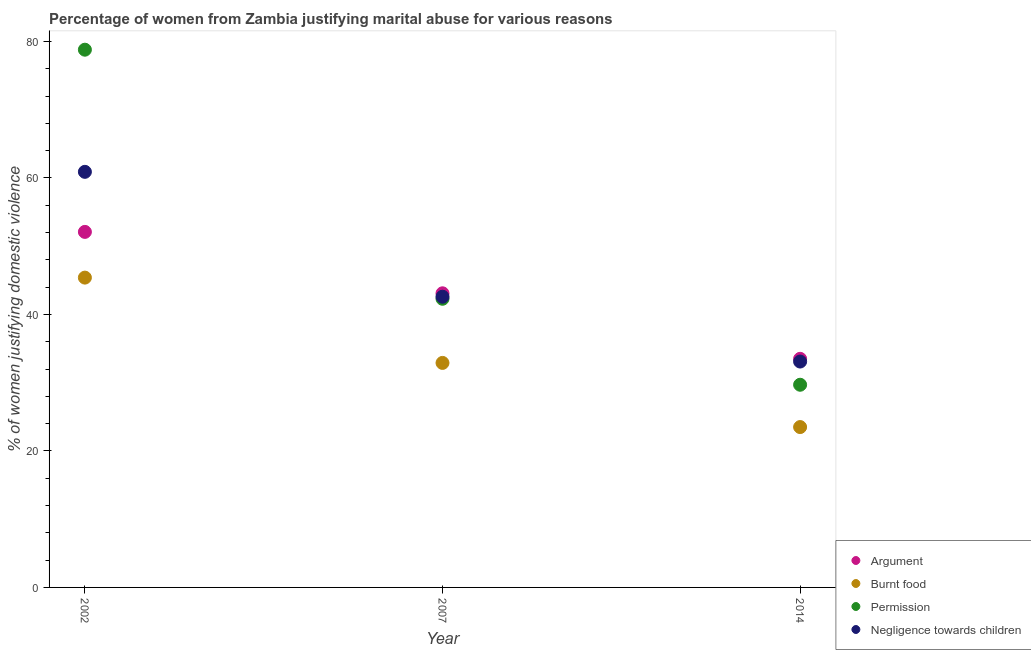How many different coloured dotlines are there?
Make the answer very short. 4. Is the number of dotlines equal to the number of legend labels?
Offer a terse response. Yes. What is the percentage of women justifying abuse for going without permission in 2007?
Give a very brief answer. 42.3. Across all years, what is the maximum percentage of women justifying abuse in the case of an argument?
Your answer should be very brief. 52.1. Across all years, what is the minimum percentage of women justifying abuse for showing negligence towards children?
Your response must be concise. 33.1. In which year was the percentage of women justifying abuse in the case of an argument maximum?
Your answer should be compact. 2002. In which year was the percentage of women justifying abuse for burning food minimum?
Keep it short and to the point. 2014. What is the total percentage of women justifying abuse for showing negligence towards children in the graph?
Your answer should be compact. 136.6. What is the difference between the percentage of women justifying abuse for going without permission in 2007 and that in 2014?
Offer a terse response. 12.6. What is the difference between the percentage of women justifying abuse for burning food in 2007 and the percentage of women justifying abuse for going without permission in 2002?
Keep it short and to the point. -45.9. What is the average percentage of women justifying abuse in the case of an argument per year?
Ensure brevity in your answer.  42.9. In the year 2007, what is the difference between the percentage of women justifying abuse for going without permission and percentage of women justifying abuse for burning food?
Offer a very short reply. 9.4. In how many years, is the percentage of women justifying abuse for showing negligence towards children greater than 16 %?
Your answer should be compact. 3. What is the ratio of the percentage of women justifying abuse for showing negligence towards children in 2002 to that in 2014?
Ensure brevity in your answer.  1.84. What is the difference between the highest and the lowest percentage of women justifying abuse for showing negligence towards children?
Provide a short and direct response. 27.8. In how many years, is the percentage of women justifying abuse for showing negligence towards children greater than the average percentage of women justifying abuse for showing negligence towards children taken over all years?
Your answer should be compact. 1. Is it the case that in every year, the sum of the percentage of women justifying abuse for burning food and percentage of women justifying abuse for showing negligence towards children is greater than the sum of percentage of women justifying abuse for going without permission and percentage of women justifying abuse in the case of an argument?
Ensure brevity in your answer.  No. Is it the case that in every year, the sum of the percentage of women justifying abuse in the case of an argument and percentage of women justifying abuse for burning food is greater than the percentage of women justifying abuse for going without permission?
Make the answer very short. Yes. Does the percentage of women justifying abuse in the case of an argument monotonically increase over the years?
Provide a short and direct response. No. How many years are there in the graph?
Make the answer very short. 3. What is the difference between two consecutive major ticks on the Y-axis?
Your answer should be compact. 20. Are the values on the major ticks of Y-axis written in scientific E-notation?
Provide a succinct answer. No. How are the legend labels stacked?
Offer a very short reply. Vertical. What is the title of the graph?
Provide a short and direct response. Percentage of women from Zambia justifying marital abuse for various reasons. Does "Finland" appear as one of the legend labels in the graph?
Give a very brief answer. No. What is the label or title of the X-axis?
Make the answer very short. Year. What is the label or title of the Y-axis?
Your answer should be very brief. % of women justifying domestic violence. What is the % of women justifying domestic violence in Argument in 2002?
Make the answer very short. 52.1. What is the % of women justifying domestic violence in Burnt food in 2002?
Your answer should be compact. 45.4. What is the % of women justifying domestic violence of Permission in 2002?
Ensure brevity in your answer.  78.8. What is the % of women justifying domestic violence in Negligence towards children in 2002?
Keep it short and to the point. 60.9. What is the % of women justifying domestic violence in Argument in 2007?
Provide a short and direct response. 43.1. What is the % of women justifying domestic violence of Burnt food in 2007?
Your response must be concise. 32.9. What is the % of women justifying domestic violence of Permission in 2007?
Offer a terse response. 42.3. What is the % of women justifying domestic violence of Negligence towards children in 2007?
Give a very brief answer. 42.6. What is the % of women justifying domestic violence of Argument in 2014?
Provide a short and direct response. 33.5. What is the % of women justifying domestic violence in Permission in 2014?
Give a very brief answer. 29.7. What is the % of women justifying domestic violence of Negligence towards children in 2014?
Your answer should be compact. 33.1. Across all years, what is the maximum % of women justifying domestic violence of Argument?
Provide a short and direct response. 52.1. Across all years, what is the maximum % of women justifying domestic violence in Burnt food?
Ensure brevity in your answer.  45.4. Across all years, what is the maximum % of women justifying domestic violence of Permission?
Offer a terse response. 78.8. Across all years, what is the maximum % of women justifying domestic violence of Negligence towards children?
Offer a terse response. 60.9. Across all years, what is the minimum % of women justifying domestic violence of Argument?
Offer a terse response. 33.5. Across all years, what is the minimum % of women justifying domestic violence in Burnt food?
Your answer should be very brief. 23.5. Across all years, what is the minimum % of women justifying domestic violence in Permission?
Ensure brevity in your answer.  29.7. Across all years, what is the minimum % of women justifying domestic violence of Negligence towards children?
Your answer should be compact. 33.1. What is the total % of women justifying domestic violence of Argument in the graph?
Ensure brevity in your answer.  128.7. What is the total % of women justifying domestic violence in Burnt food in the graph?
Your response must be concise. 101.8. What is the total % of women justifying domestic violence in Permission in the graph?
Your response must be concise. 150.8. What is the total % of women justifying domestic violence in Negligence towards children in the graph?
Keep it short and to the point. 136.6. What is the difference between the % of women justifying domestic violence of Permission in 2002 and that in 2007?
Make the answer very short. 36.5. What is the difference between the % of women justifying domestic violence of Argument in 2002 and that in 2014?
Give a very brief answer. 18.6. What is the difference between the % of women justifying domestic violence of Burnt food in 2002 and that in 2014?
Offer a very short reply. 21.9. What is the difference between the % of women justifying domestic violence of Permission in 2002 and that in 2014?
Ensure brevity in your answer.  49.1. What is the difference between the % of women justifying domestic violence in Negligence towards children in 2002 and that in 2014?
Your answer should be very brief. 27.8. What is the difference between the % of women justifying domestic violence in Argument in 2007 and that in 2014?
Provide a short and direct response. 9.6. What is the difference between the % of women justifying domestic violence of Negligence towards children in 2007 and that in 2014?
Ensure brevity in your answer.  9.5. What is the difference between the % of women justifying domestic violence in Permission in 2002 and the % of women justifying domestic violence in Negligence towards children in 2007?
Offer a very short reply. 36.2. What is the difference between the % of women justifying domestic violence of Argument in 2002 and the % of women justifying domestic violence of Burnt food in 2014?
Offer a very short reply. 28.6. What is the difference between the % of women justifying domestic violence of Argument in 2002 and the % of women justifying domestic violence of Permission in 2014?
Ensure brevity in your answer.  22.4. What is the difference between the % of women justifying domestic violence of Argument in 2002 and the % of women justifying domestic violence of Negligence towards children in 2014?
Make the answer very short. 19. What is the difference between the % of women justifying domestic violence of Permission in 2002 and the % of women justifying domestic violence of Negligence towards children in 2014?
Offer a very short reply. 45.7. What is the difference between the % of women justifying domestic violence of Argument in 2007 and the % of women justifying domestic violence of Burnt food in 2014?
Offer a terse response. 19.6. What is the difference between the % of women justifying domestic violence in Argument in 2007 and the % of women justifying domestic violence in Negligence towards children in 2014?
Your answer should be very brief. 10. What is the difference between the % of women justifying domestic violence of Burnt food in 2007 and the % of women justifying domestic violence of Permission in 2014?
Provide a short and direct response. 3.2. What is the difference between the % of women justifying domestic violence of Permission in 2007 and the % of women justifying domestic violence of Negligence towards children in 2014?
Offer a terse response. 9.2. What is the average % of women justifying domestic violence in Argument per year?
Offer a very short reply. 42.9. What is the average % of women justifying domestic violence of Burnt food per year?
Your answer should be very brief. 33.93. What is the average % of women justifying domestic violence in Permission per year?
Give a very brief answer. 50.27. What is the average % of women justifying domestic violence of Negligence towards children per year?
Your answer should be compact. 45.53. In the year 2002, what is the difference between the % of women justifying domestic violence of Argument and % of women justifying domestic violence of Permission?
Your answer should be very brief. -26.7. In the year 2002, what is the difference between the % of women justifying domestic violence in Argument and % of women justifying domestic violence in Negligence towards children?
Your response must be concise. -8.8. In the year 2002, what is the difference between the % of women justifying domestic violence in Burnt food and % of women justifying domestic violence in Permission?
Offer a terse response. -33.4. In the year 2002, what is the difference between the % of women justifying domestic violence in Burnt food and % of women justifying domestic violence in Negligence towards children?
Keep it short and to the point. -15.5. In the year 2007, what is the difference between the % of women justifying domestic violence of Argument and % of women justifying domestic violence of Permission?
Offer a terse response. 0.8. In the year 2007, what is the difference between the % of women justifying domestic violence in Burnt food and % of women justifying domestic violence in Permission?
Your answer should be very brief. -9.4. In the year 2007, what is the difference between the % of women justifying domestic violence in Burnt food and % of women justifying domestic violence in Negligence towards children?
Provide a short and direct response. -9.7. In the year 2007, what is the difference between the % of women justifying domestic violence of Permission and % of women justifying domestic violence of Negligence towards children?
Offer a very short reply. -0.3. In the year 2014, what is the difference between the % of women justifying domestic violence in Argument and % of women justifying domestic violence in Burnt food?
Provide a succinct answer. 10. In the year 2014, what is the difference between the % of women justifying domestic violence of Argument and % of women justifying domestic violence of Negligence towards children?
Offer a very short reply. 0.4. In the year 2014, what is the difference between the % of women justifying domestic violence of Burnt food and % of women justifying domestic violence of Negligence towards children?
Your answer should be compact. -9.6. In the year 2014, what is the difference between the % of women justifying domestic violence of Permission and % of women justifying domestic violence of Negligence towards children?
Provide a succinct answer. -3.4. What is the ratio of the % of women justifying domestic violence in Argument in 2002 to that in 2007?
Make the answer very short. 1.21. What is the ratio of the % of women justifying domestic violence in Burnt food in 2002 to that in 2007?
Provide a short and direct response. 1.38. What is the ratio of the % of women justifying domestic violence in Permission in 2002 to that in 2007?
Your answer should be compact. 1.86. What is the ratio of the % of women justifying domestic violence in Negligence towards children in 2002 to that in 2007?
Your answer should be compact. 1.43. What is the ratio of the % of women justifying domestic violence in Argument in 2002 to that in 2014?
Keep it short and to the point. 1.56. What is the ratio of the % of women justifying domestic violence in Burnt food in 2002 to that in 2014?
Offer a terse response. 1.93. What is the ratio of the % of women justifying domestic violence of Permission in 2002 to that in 2014?
Your answer should be compact. 2.65. What is the ratio of the % of women justifying domestic violence of Negligence towards children in 2002 to that in 2014?
Offer a very short reply. 1.84. What is the ratio of the % of women justifying domestic violence of Argument in 2007 to that in 2014?
Ensure brevity in your answer.  1.29. What is the ratio of the % of women justifying domestic violence of Burnt food in 2007 to that in 2014?
Your answer should be very brief. 1.4. What is the ratio of the % of women justifying domestic violence of Permission in 2007 to that in 2014?
Your answer should be very brief. 1.42. What is the ratio of the % of women justifying domestic violence in Negligence towards children in 2007 to that in 2014?
Your response must be concise. 1.29. What is the difference between the highest and the second highest % of women justifying domestic violence in Permission?
Your answer should be compact. 36.5. What is the difference between the highest and the lowest % of women justifying domestic violence in Argument?
Provide a succinct answer. 18.6. What is the difference between the highest and the lowest % of women justifying domestic violence in Burnt food?
Keep it short and to the point. 21.9. What is the difference between the highest and the lowest % of women justifying domestic violence in Permission?
Your answer should be very brief. 49.1. What is the difference between the highest and the lowest % of women justifying domestic violence in Negligence towards children?
Make the answer very short. 27.8. 